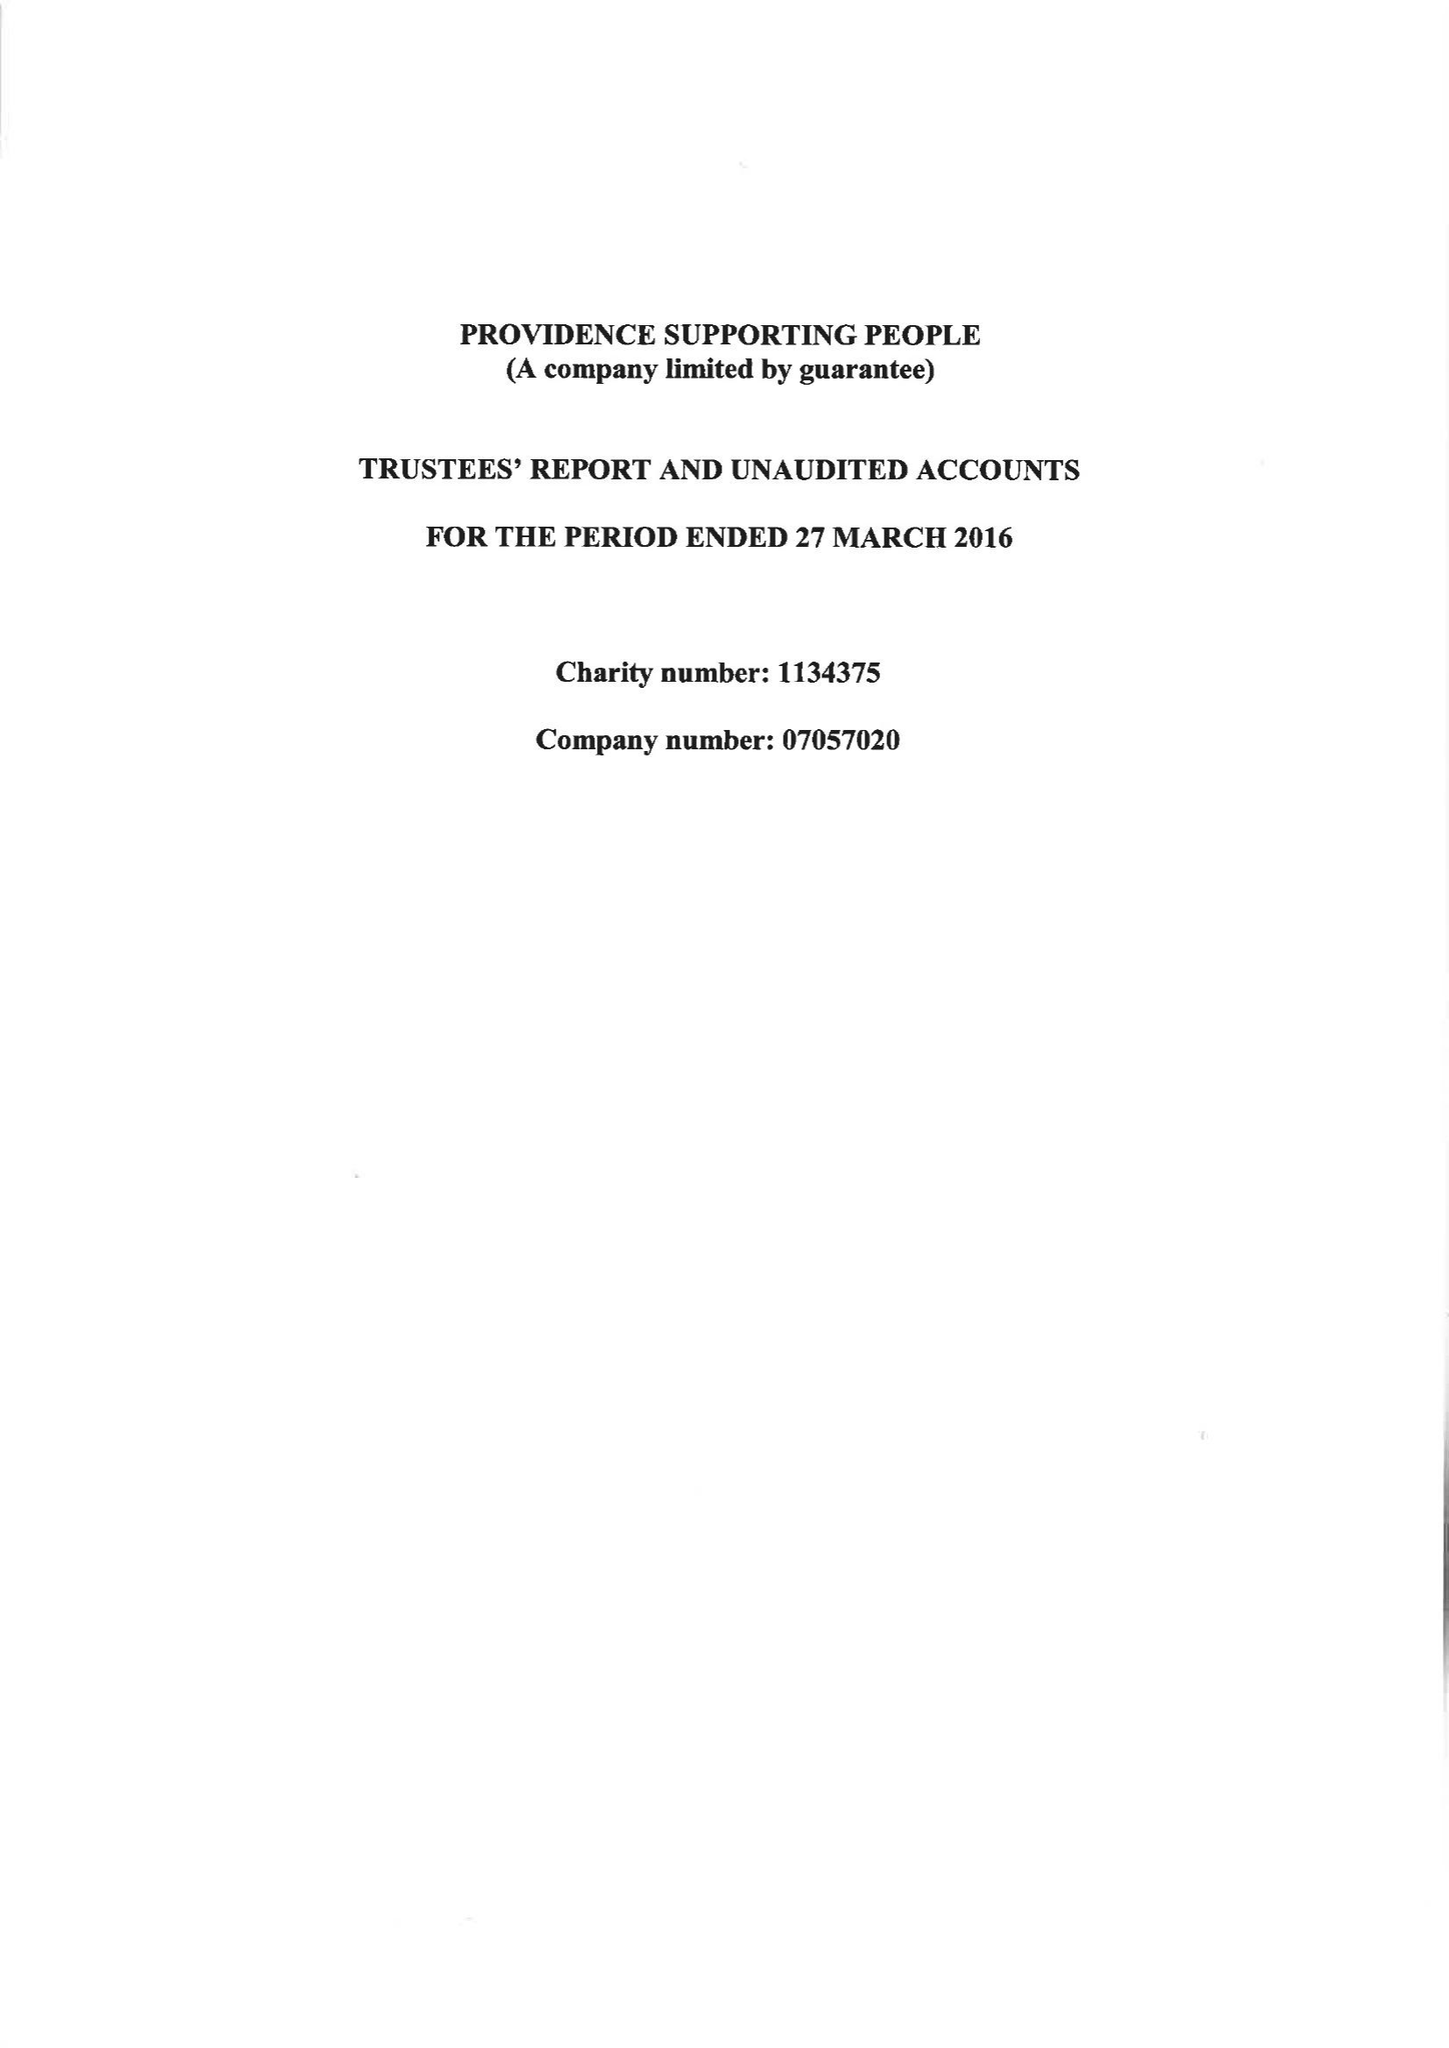What is the value for the address__postcode?
Answer the question using a single word or phrase. BH1 4EJ 